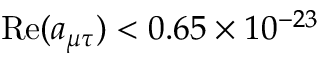<formula> <loc_0><loc_0><loc_500><loc_500>R e ( a _ { \mu \tau } ) < 0 . 6 5 \times 1 0 ^ { - 2 3 }</formula> 